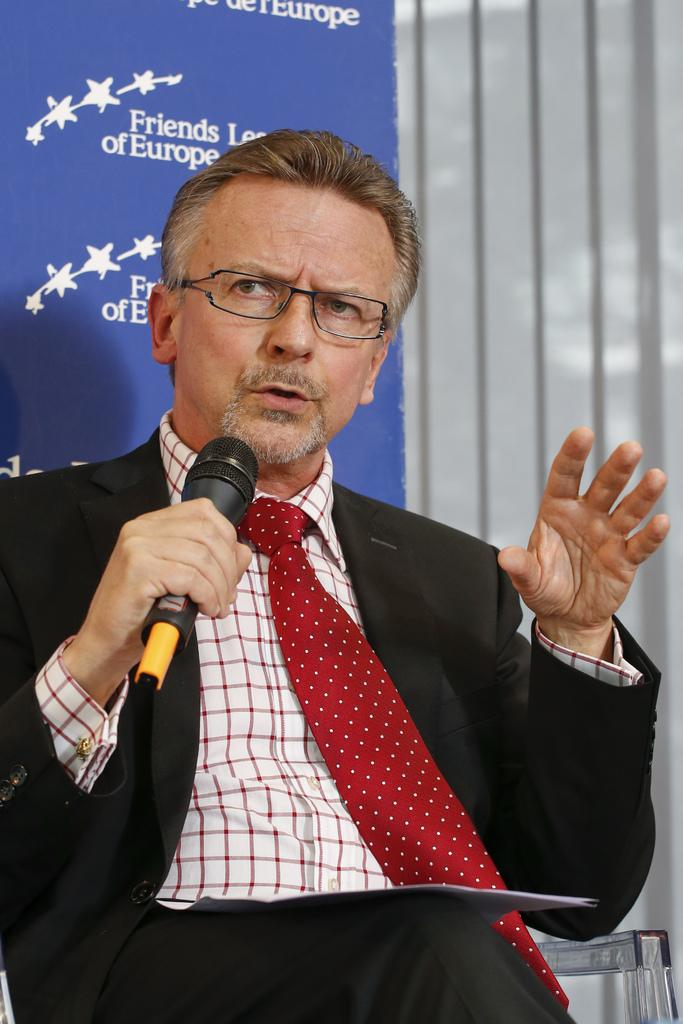What is the main subject of the image? There is a person in the image. What is the person holding in the image? The person is holding a microphone. What else can be seen in the image besides the person? There is a board with text in the image. Where is the board located in relation to the person? The board is behind the person. Can you tell me how many hens are visible on the board in the image? There are no hens present on the board or in the image. 